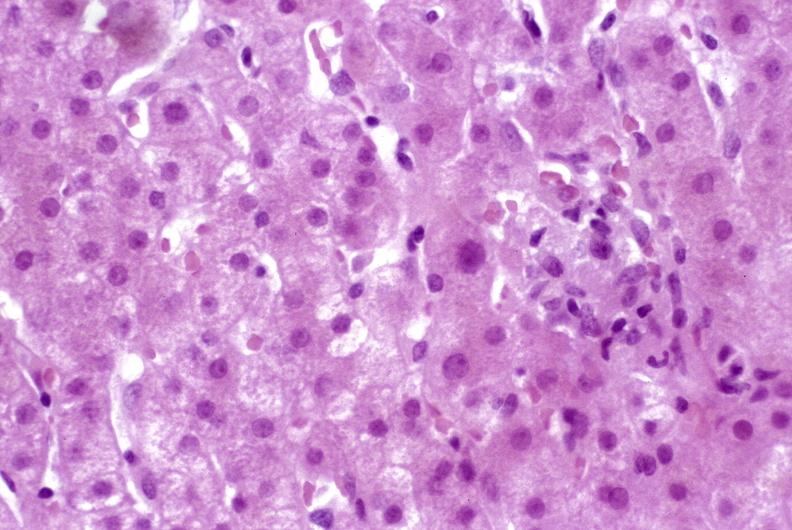s hepatobiliary present?
Answer the question using a single word or phrase. Yes 